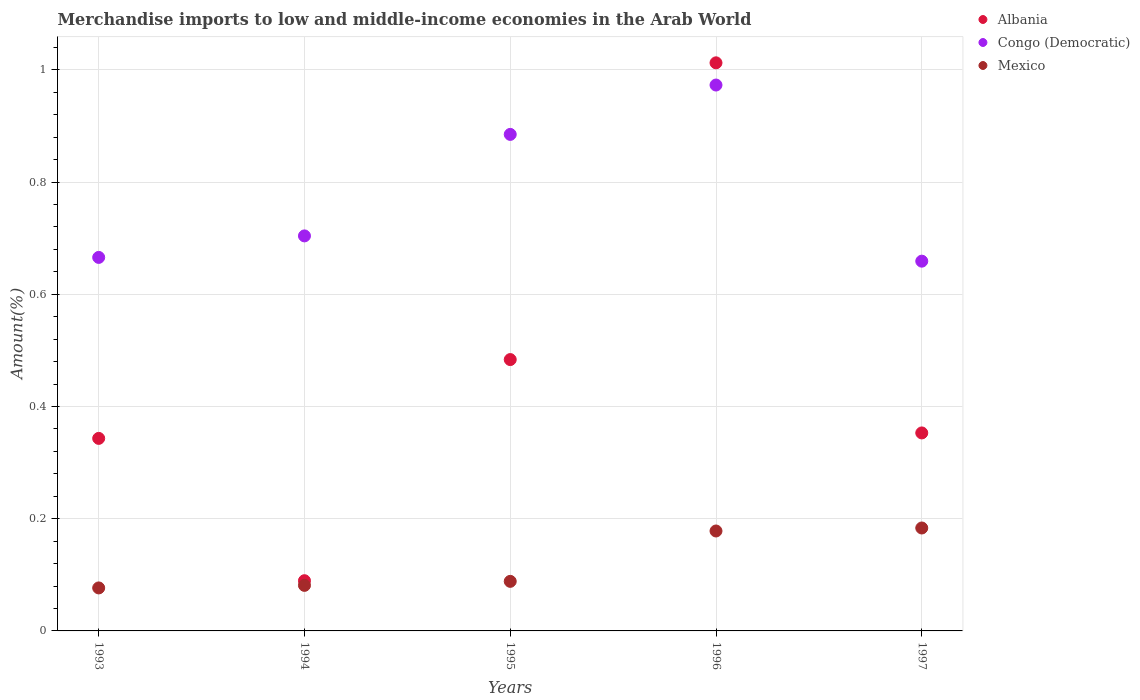How many different coloured dotlines are there?
Your response must be concise. 3. What is the percentage of amount earned from merchandise imports in Congo (Democratic) in 1997?
Offer a very short reply. 0.66. Across all years, what is the maximum percentage of amount earned from merchandise imports in Mexico?
Your answer should be very brief. 0.18. Across all years, what is the minimum percentage of amount earned from merchandise imports in Albania?
Ensure brevity in your answer.  0.09. In which year was the percentage of amount earned from merchandise imports in Mexico maximum?
Make the answer very short. 1997. What is the total percentage of amount earned from merchandise imports in Mexico in the graph?
Give a very brief answer. 0.61. What is the difference between the percentage of amount earned from merchandise imports in Mexico in 1993 and that in 1997?
Give a very brief answer. -0.11. What is the difference between the percentage of amount earned from merchandise imports in Albania in 1993 and the percentage of amount earned from merchandise imports in Mexico in 1996?
Keep it short and to the point. 0.17. What is the average percentage of amount earned from merchandise imports in Mexico per year?
Keep it short and to the point. 0.12. In the year 1995, what is the difference between the percentage of amount earned from merchandise imports in Albania and percentage of amount earned from merchandise imports in Mexico?
Provide a succinct answer. 0.4. What is the ratio of the percentage of amount earned from merchandise imports in Mexico in 1994 to that in 1996?
Offer a terse response. 0.46. Is the difference between the percentage of amount earned from merchandise imports in Albania in 1993 and 1995 greater than the difference between the percentage of amount earned from merchandise imports in Mexico in 1993 and 1995?
Your answer should be very brief. No. What is the difference between the highest and the second highest percentage of amount earned from merchandise imports in Congo (Democratic)?
Offer a terse response. 0.09. What is the difference between the highest and the lowest percentage of amount earned from merchandise imports in Albania?
Offer a very short reply. 0.92. Is the sum of the percentage of amount earned from merchandise imports in Albania in 1993 and 1997 greater than the maximum percentage of amount earned from merchandise imports in Mexico across all years?
Give a very brief answer. Yes. What is the difference between two consecutive major ticks on the Y-axis?
Your answer should be very brief. 0.2. Are the values on the major ticks of Y-axis written in scientific E-notation?
Offer a terse response. No. Does the graph contain any zero values?
Keep it short and to the point. No. How many legend labels are there?
Your answer should be very brief. 3. What is the title of the graph?
Your response must be concise. Merchandise imports to low and middle-income economies in the Arab World. Does "Jamaica" appear as one of the legend labels in the graph?
Keep it short and to the point. No. What is the label or title of the Y-axis?
Keep it short and to the point. Amount(%). What is the Amount(%) in Albania in 1993?
Your answer should be compact. 0.34. What is the Amount(%) in Congo (Democratic) in 1993?
Offer a very short reply. 0.67. What is the Amount(%) of Mexico in 1993?
Your response must be concise. 0.08. What is the Amount(%) of Albania in 1994?
Your answer should be very brief. 0.09. What is the Amount(%) of Congo (Democratic) in 1994?
Offer a very short reply. 0.7. What is the Amount(%) in Mexico in 1994?
Keep it short and to the point. 0.08. What is the Amount(%) of Albania in 1995?
Make the answer very short. 0.48. What is the Amount(%) in Congo (Democratic) in 1995?
Ensure brevity in your answer.  0.89. What is the Amount(%) in Mexico in 1995?
Your response must be concise. 0.09. What is the Amount(%) of Albania in 1996?
Provide a short and direct response. 1.01. What is the Amount(%) in Congo (Democratic) in 1996?
Provide a succinct answer. 0.97. What is the Amount(%) of Mexico in 1996?
Offer a very short reply. 0.18. What is the Amount(%) of Albania in 1997?
Your answer should be compact. 0.35. What is the Amount(%) of Congo (Democratic) in 1997?
Give a very brief answer. 0.66. What is the Amount(%) in Mexico in 1997?
Give a very brief answer. 0.18. Across all years, what is the maximum Amount(%) of Albania?
Give a very brief answer. 1.01. Across all years, what is the maximum Amount(%) in Congo (Democratic)?
Offer a terse response. 0.97. Across all years, what is the maximum Amount(%) in Mexico?
Make the answer very short. 0.18. Across all years, what is the minimum Amount(%) of Albania?
Your response must be concise. 0.09. Across all years, what is the minimum Amount(%) in Congo (Democratic)?
Your answer should be very brief. 0.66. Across all years, what is the minimum Amount(%) of Mexico?
Ensure brevity in your answer.  0.08. What is the total Amount(%) in Albania in the graph?
Offer a very short reply. 2.28. What is the total Amount(%) in Congo (Democratic) in the graph?
Keep it short and to the point. 3.89. What is the total Amount(%) of Mexico in the graph?
Provide a succinct answer. 0.61. What is the difference between the Amount(%) in Albania in 1993 and that in 1994?
Offer a very short reply. 0.25. What is the difference between the Amount(%) in Congo (Democratic) in 1993 and that in 1994?
Ensure brevity in your answer.  -0.04. What is the difference between the Amount(%) in Mexico in 1993 and that in 1994?
Ensure brevity in your answer.  -0. What is the difference between the Amount(%) of Albania in 1993 and that in 1995?
Offer a terse response. -0.14. What is the difference between the Amount(%) in Congo (Democratic) in 1993 and that in 1995?
Your answer should be compact. -0.22. What is the difference between the Amount(%) in Mexico in 1993 and that in 1995?
Give a very brief answer. -0.01. What is the difference between the Amount(%) in Albania in 1993 and that in 1996?
Keep it short and to the point. -0.67. What is the difference between the Amount(%) in Congo (Democratic) in 1993 and that in 1996?
Your answer should be very brief. -0.31. What is the difference between the Amount(%) of Mexico in 1993 and that in 1996?
Give a very brief answer. -0.1. What is the difference between the Amount(%) in Albania in 1993 and that in 1997?
Provide a succinct answer. -0.01. What is the difference between the Amount(%) of Congo (Democratic) in 1993 and that in 1997?
Provide a succinct answer. 0.01. What is the difference between the Amount(%) of Mexico in 1993 and that in 1997?
Offer a terse response. -0.11. What is the difference between the Amount(%) of Albania in 1994 and that in 1995?
Make the answer very short. -0.39. What is the difference between the Amount(%) in Congo (Democratic) in 1994 and that in 1995?
Your answer should be very brief. -0.18. What is the difference between the Amount(%) in Mexico in 1994 and that in 1995?
Make the answer very short. -0.01. What is the difference between the Amount(%) in Albania in 1994 and that in 1996?
Provide a short and direct response. -0.92. What is the difference between the Amount(%) of Congo (Democratic) in 1994 and that in 1996?
Provide a succinct answer. -0.27. What is the difference between the Amount(%) in Mexico in 1994 and that in 1996?
Provide a short and direct response. -0.1. What is the difference between the Amount(%) of Albania in 1994 and that in 1997?
Make the answer very short. -0.26. What is the difference between the Amount(%) in Congo (Democratic) in 1994 and that in 1997?
Keep it short and to the point. 0.04. What is the difference between the Amount(%) of Mexico in 1994 and that in 1997?
Your answer should be very brief. -0.1. What is the difference between the Amount(%) of Albania in 1995 and that in 1996?
Offer a terse response. -0.53. What is the difference between the Amount(%) in Congo (Democratic) in 1995 and that in 1996?
Provide a succinct answer. -0.09. What is the difference between the Amount(%) of Mexico in 1995 and that in 1996?
Give a very brief answer. -0.09. What is the difference between the Amount(%) in Albania in 1995 and that in 1997?
Offer a terse response. 0.13. What is the difference between the Amount(%) in Congo (Democratic) in 1995 and that in 1997?
Your answer should be very brief. 0.23. What is the difference between the Amount(%) in Mexico in 1995 and that in 1997?
Keep it short and to the point. -0.1. What is the difference between the Amount(%) of Albania in 1996 and that in 1997?
Your answer should be very brief. 0.66. What is the difference between the Amount(%) of Congo (Democratic) in 1996 and that in 1997?
Your response must be concise. 0.31. What is the difference between the Amount(%) in Mexico in 1996 and that in 1997?
Offer a terse response. -0.01. What is the difference between the Amount(%) of Albania in 1993 and the Amount(%) of Congo (Democratic) in 1994?
Your answer should be compact. -0.36. What is the difference between the Amount(%) in Albania in 1993 and the Amount(%) in Mexico in 1994?
Your answer should be compact. 0.26. What is the difference between the Amount(%) in Congo (Democratic) in 1993 and the Amount(%) in Mexico in 1994?
Ensure brevity in your answer.  0.58. What is the difference between the Amount(%) of Albania in 1993 and the Amount(%) of Congo (Democratic) in 1995?
Provide a succinct answer. -0.54. What is the difference between the Amount(%) of Albania in 1993 and the Amount(%) of Mexico in 1995?
Make the answer very short. 0.25. What is the difference between the Amount(%) in Congo (Democratic) in 1993 and the Amount(%) in Mexico in 1995?
Keep it short and to the point. 0.58. What is the difference between the Amount(%) of Albania in 1993 and the Amount(%) of Congo (Democratic) in 1996?
Provide a short and direct response. -0.63. What is the difference between the Amount(%) of Albania in 1993 and the Amount(%) of Mexico in 1996?
Make the answer very short. 0.17. What is the difference between the Amount(%) in Congo (Democratic) in 1993 and the Amount(%) in Mexico in 1996?
Offer a very short reply. 0.49. What is the difference between the Amount(%) in Albania in 1993 and the Amount(%) in Congo (Democratic) in 1997?
Offer a terse response. -0.32. What is the difference between the Amount(%) of Albania in 1993 and the Amount(%) of Mexico in 1997?
Keep it short and to the point. 0.16. What is the difference between the Amount(%) in Congo (Democratic) in 1993 and the Amount(%) in Mexico in 1997?
Provide a succinct answer. 0.48. What is the difference between the Amount(%) of Albania in 1994 and the Amount(%) of Congo (Democratic) in 1995?
Make the answer very short. -0.8. What is the difference between the Amount(%) in Albania in 1994 and the Amount(%) in Mexico in 1995?
Your response must be concise. 0. What is the difference between the Amount(%) in Congo (Democratic) in 1994 and the Amount(%) in Mexico in 1995?
Your answer should be compact. 0.62. What is the difference between the Amount(%) of Albania in 1994 and the Amount(%) of Congo (Democratic) in 1996?
Your answer should be very brief. -0.88. What is the difference between the Amount(%) in Albania in 1994 and the Amount(%) in Mexico in 1996?
Provide a short and direct response. -0.09. What is the difference between the Amount(%) of Congo (Democratic) in 1994 and the Amount(%) of Mexico in 1996?
Your answer should be compact. 0.53. What is the difference between the Amount(%) of Albania in 1994 and the Amount(%) of Congo (Democratic) in 1997?
Ensure brevity in your answer.  -0.57. What is the difference between the Amount(%) of Albania in 1994 and the Amount(%) of Mexico in 1997?
Offer a very short reply. -0.09. What is the difference between the Amount(%) of Congo (Democratic) in 1994 and the Amount(%) of Mexico in 1997?
Provide a short and direct response. 0.52. What is the difference between the Amount(%) in Albania in 1995 and the Amount(%) in Congo (Democratic) in 1996?
Give a very brief answer. -0.49. What is the difference between the Amount(%) in Albania in 1995 and the Amount(%) in Mexico in 1996?
Provide a succinct answer. 0.31. What is the difference between the Amount(%) of Congo (Democratic) in 1995 and the Amount(%) of Mexico in 1996?
Give a very brief answer. 0.71. What is the difference between the Amount(%) in Albania in 1995 and the Amount(%) in Congo (Democratic) in 1997?
Make the answer very short. -0.18. What is the difference between the Amount(%) in Albania in 1995 and the Amount(%) in Mexico in 1997?
Provide a short and direct response. 0.3. What is the difference between the Amount(%) in Congo (Democratic) in 1995 and the Amount(%) in Mexico in 1997?
Ensure brevity in your answer.  0.7. What is the difference between the Amount(%) of Albania in 1996 and the Amount(%) of Congo (Democratic) in 1997?
Ensure brevity in your answer.  0.35. What is the difference between the Amount(%) of Albania in 1996 and the Amount(%) of Mexico in 1997?
Make the answer very short. 0.83. What is the difference between the Amount(%) of Congo (Democratic) in 1996 and the Amount(%) of Mexico in 1997?
Keep it short and to the point. 0.79. What is the average Amount(%) in Albania per year?
Provide a succinct answer. 0.46. What is the average Amount(%) in Congo (Democratic) per year?
Offer a terse response. 0.78. What is the average Amount(%) of Mexico per year?
Give a very brief answer. 0.12. In the year 1993, what is the difference between the Amount(%) in Albania and Amount(%) in Congo (Democratic)?
Your response must be concise. -0.32. In the year 1993, what is the difference between the Amount(%) of Albania and Amount(%) of Mexico?
Provide a succinct answer. 0.27. In the year 1993, what is the difference between the Amount(%) of Congo (Democratic) and Amount(%) of Mexico?
Offer a terse response. 0.59. In the year 1994, what is the difference between the Amount(%) of Albania and Amount(%) of Congo (Democratic)?
Provide a short and direct response. -0.61. In the year 1994, what is the difference between the Amount(%) in Albania and Amount(%) in Mexico?
Make the answer very short. 0.01. In the year 1994, what is the difference between the Amount(%) of Congo (Democratic) and Amount(%) of Mexico?
Your answer should be very brief. 0.62. In the year 1995, what is the difference between the Amount(%) of Albania and Amount(%) of Congo (Democratic)?
Keep it short and to the point. -0.4. In the year 1995, what is the difference between the Amount(%) in Albania and Amount(%) in Mexico?
Your answer should be very brief. 0.4. In the year 1995, what is the difference between the Amount(%) in Congo (Democratic) and Amount(%) in Mexico?
Your answer should be compact. 0.8. In the year 1996, what is the difference between the Amount(%) in Albania and Amount(%) in Congo (Democratic)?
Give a very brief answer. 0.04. In the year 1996, what is the difference between the Amount(%) of Albania and Amount(%) of Mexico?
Give a very brief answer. 0.83. In the year 1996, what is the difference between the Amount(%) of Congo (Democratic) and Amount(%) of Mexico?
Provide a short and direct response. 0.79. In the year 1997, what is the difference between the Amount(%) in Albania and Amount(%) in Congo (Democratic)?
Offer a terse response. -0.31. In the year 1997, what is the difference between the Amount(%) in Albania and Amount(%) in Mexico?
Your answer should be very brief. 0.17. In the year 1997, what is the difference between the Amount(%) of Congo (Democratic) and Amount(%) of Mexico?
Your response must be concise. 0.48. What is the ratio of the Amount(%) of Albania in 1993 to that in 1994?
Offer a very short reply. 3.83. What is the ratio of the Amount(%) in Congo (Democratic) in 1993 to that in 1994?
Ensure brevity in your answer.  0.95. What is the ratio of the Amount(%) in Mexico in 1993 to that in 1994?
Make the answer very short. 0.94. What is the ratio of the Amount(%) in Albania in 1993 to that in 1995?
Provide a short and direct response. 0.71. What is the ratio of the Amount(%) in Congo (Democratic) in 1993 to that in 1995?
Ensure brevity in your answer.  0.75. What is the ratio of the Amount(%) of Mexico in 1993 to that in 1995?
Your response must be concise. 0.87. What is the ratio of the Amount(%) in Albania in 1993 to that in 1996?
Offer a very short reply. 0.34. What is the ratio of the Amount(%) in Congo (Democratic) in 1993 to that in 1996?
Provide a short and direct response. 0.68. What is the ratio of the Amount(%) of Mexico in 1993 to that in 1996?
Your answer should be compact. 0.43. What is the ratio of the Amount(%) of Albania in 1993 to that in 1997?
Provide a succinct answer. 0.97. What is the ratio of the Amount(%) of Congo (Democratic) in 1993 to that in 1997?
Make the answer very short. 1.01. What is the ratio of the Amount(%) in Mexico in 1993 to that in 1997?
Your response must be concise. 0.42. What is the ratio of the Amount(%) of Albania in 1994 to that in 1995?
Provide a succinct answer. 0.19. What is the ratio of the Amount(%) of Congo (Democratic) in 1994 to that in 1995?
Ensure brevity in your answer.  0.8. What is the ratio of the Amount(%) of Mexico in 1994 to that in 1995?
Provide a succinct answer. 0.92. What is the ratio of the Amount(%) in Albania in 1994 to that in 1996?
Make the answer very short. 0.09. What is the ratio of the Amount(%) in Congo (Democratic) in 1994 to that in 1996?
Your answer should be very brief. 0.72. What is the ratio of the Amount(%) in Mexico in 1994 to that in 1996?
Provide a succinct answer. 0.46. What is the ratio of the Amount(%) in Albania in 1994 to that in 1997?
Ensure brevity in your answer.  0.25. What is the ratio of the Amount(%) of Congo (Democratic) in 1994 to that in 1997?
Offer a very short reply. 1.07. What is the ratio of the Amount(%) of Mexico in 1994 to that in 1997?
Offer a very short reply. 0.44. What is the ratio of the Amount(%) of Albania in 1995 to that in 1996?
Provide a succinct answer. 0.48. What is the ratio of the Amount(%) in Congo (Democratic) in 1995 to that in 1996?
Offer a terse response. 0.91. What is the ratio of the Amount(%) in Mexico in 1995 to that in 1996?
Offer a terse response. 0.5. What is the ratio of the Amount(%) of Albania in 1995 to that in 1997?
Keep it short and to the point. 1.37. What is the ratio of the Amount(%) of Congo (Democratic) in 1995 to that in 1997?
Your response must be concise. 1.34. What is the ratio of the Amount(%) of Mexico in 1995 to that in 1997?
Keep it short and to the point. 0.48. What is the ratio of the Amount(%) in Albania in 1996 to that in 1997?
Your answer should be very brief. 2.87. What is the ratio of the Amount(%) of Congo (Democratic) in 1996 to that in 1997?
Make the answer very short. 1.48. What is the ratio of the Amount(%) in Mexico in 1996 to that in 1997?
Offer a very short reply. 0.97. What is the difference between the highest and the second highest Amount(%) of Albania?
Give a very brief answer. 0.53. What is the difference between the highest and the second highest Amount(%) in Congo (Democratic)?
Offer a terse response. 0.09. What is the difference between the highest and the second highest Amount(%) of Mexico?
Your answer should be very brief. 0.01. What is the difference between the highest and the lowest Amount(%) of Congo (Democratic)?
Your answer should be compact. 0.31. What is the difference between the highest and the lowest Amount(%) in Mexico?
Provide a short and direct response. 0.11. 